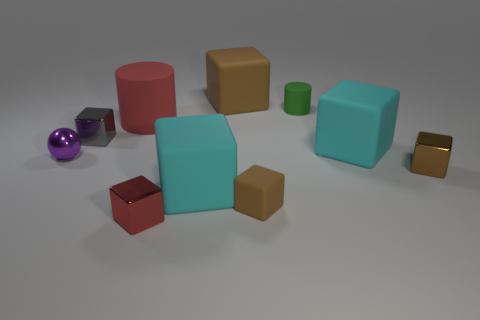Is there any other thing that has the same shape as the small purple shiny object?
Provide a succinct answer. No. Are there fewer red metal blocks right of the small brown metal block than big shiny cylinders?
Keep it short and to the point. No. There is a shiny object that is right of the thing that is in front of the brown rubber cube in front of the big red cylinder; what shape is it?
Your answer should be very brief. Cube. Are there more shiny balls than small green matte balls?
Ensure brevity in your answer.  Yes. How many other things are there of the same material as the tiny ball?
Give a very brief answer. 3. How many things are brown blocks or large matte cubes behind the gray cube?
Your answer should be compact. 3. Is the number of large matte cubes less than the number of big matte things?
Your answer should be compact. Yes. There is a tiny metal object behind the big cyan block that is behind the brown object that is on the right side of the tiny brown matte thing; what is its color?
Your answer should be compact. Gray. Does the tiny purple thing have the same material as the large red object?
Give a very brief answer. No. How many cylinders are in front of the purple ball?
Make the answer very short. 0. 